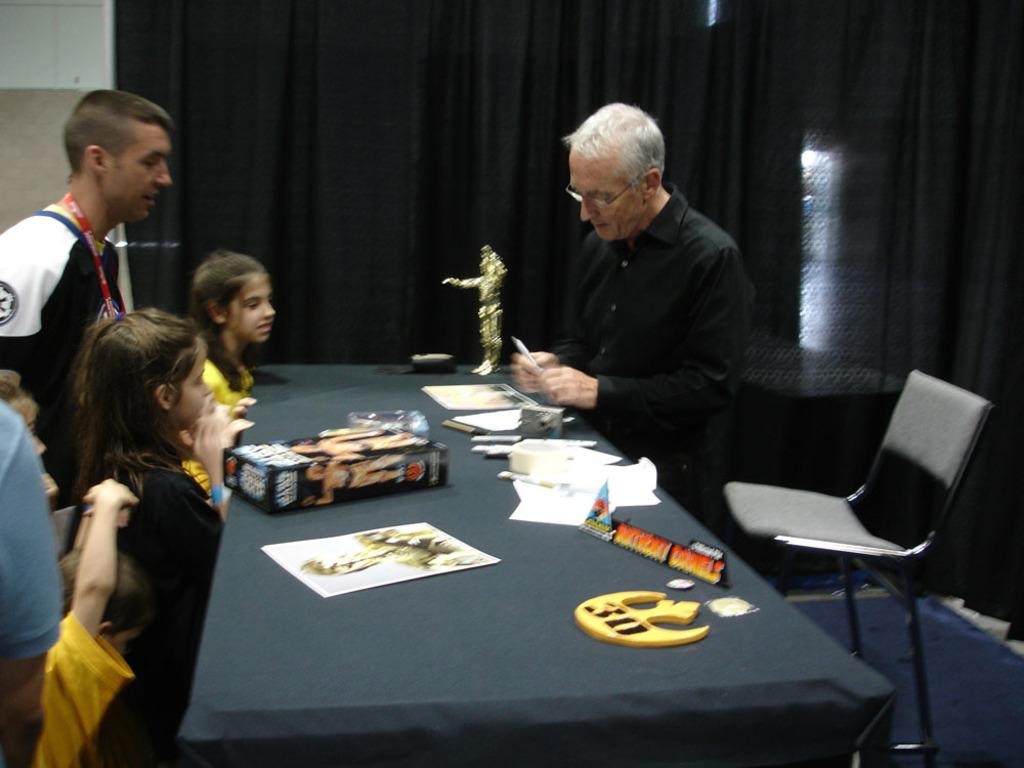How many kids are at the table in the image? There are 4 kids at the table. How many men are at the table in the image? There are 3 men at the table. What objects are on the table in the image? There is a box, papers, a camera, and a statue on the table. What can be seen in the background of the image? There is a chair, a wall, and a curtain in the background. What type of muscle is visible on the statue in the image? There is no muscle visible on the statue in the image, as the statue is not described in detail. What is the reaction of the people at the table to the disgusting smell in the image? There is no mention of a disgusting smell in the image, so it cannot be determined how the people at the table would react. 